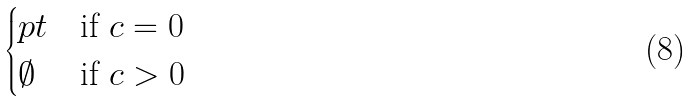Convert formula to latex. <formula><loc_0><loc_0><loc_500><loc_500>\begin{cases} p t & \text {if $c=0$} \\ \emptyset & \text {if $c >0$} \end{cases}</formula> 